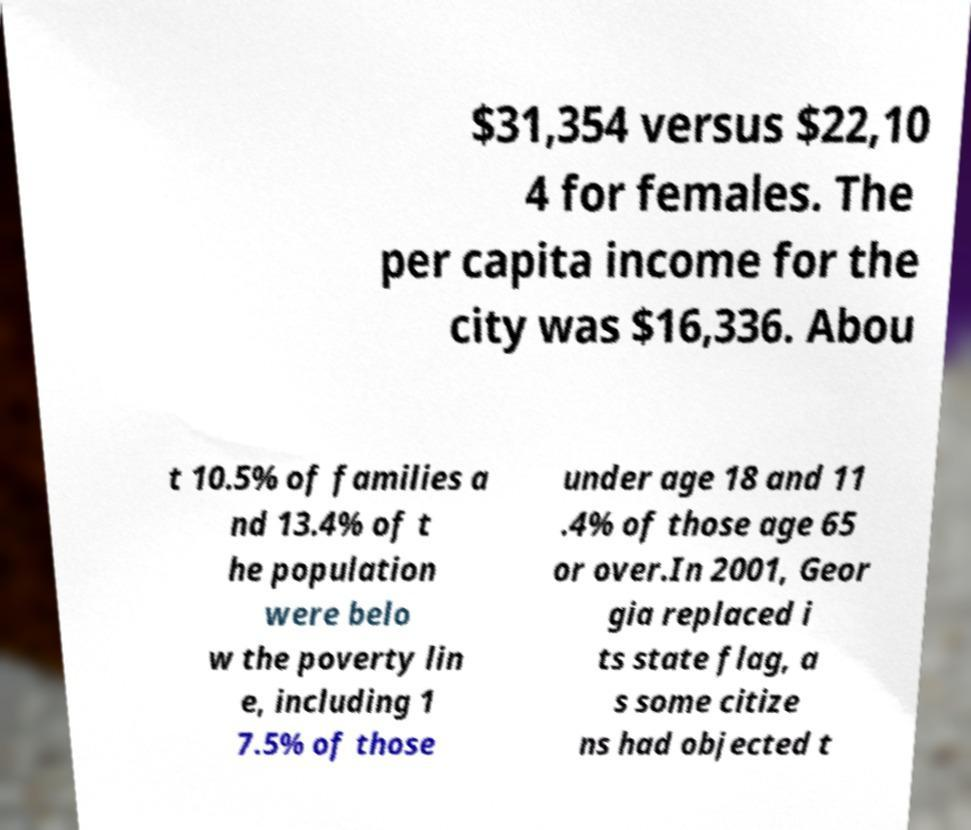Please read and relay the text visible in this image. What does it say? $31,354 versus $22,10 4 for females. The per capita income for the city was $16,336. Abou t 10.5% of families a nd 13.4% of t he population were belo w the poverty lin e, including 1 7.5% of those under age 18 and 11 .4% of those age 65 or over.In 2001, Geor gia replaced i ts state flag, a s some citize ns had objected t 